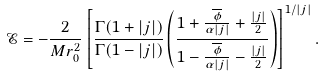<formula> <loc_0><loc_0><loc_500><loc_500>\mathcal { E } = - \frac { 2 } { M r _ { 0 } ^ { 2 } } \left [ \frac { \Gamma ( 1 + | j | ) } { \Gamma ( 1 - | j | ) } \left ( \frac { 1 + \frac { \overline { \phi } } { \alpha | j | } + \frac { | j | } { 2 } } { 1 - \frac { \overline { \phi } } { \alpha | j | } - \frac { | j | } { 2 } } \right ) \right ] ^ { 1 / | j | } .</formula> 